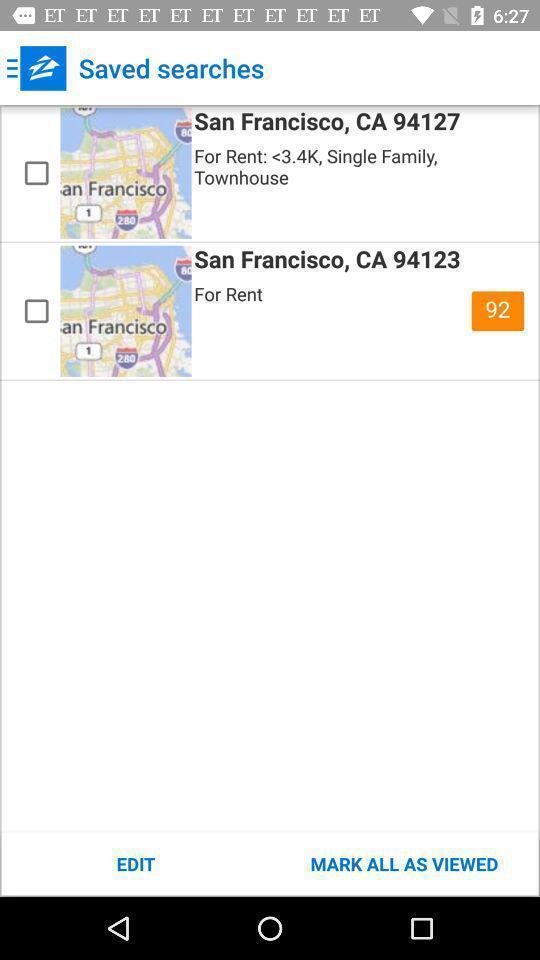Provide a detailed account of this screenshot. Page displaying the saved searches. 